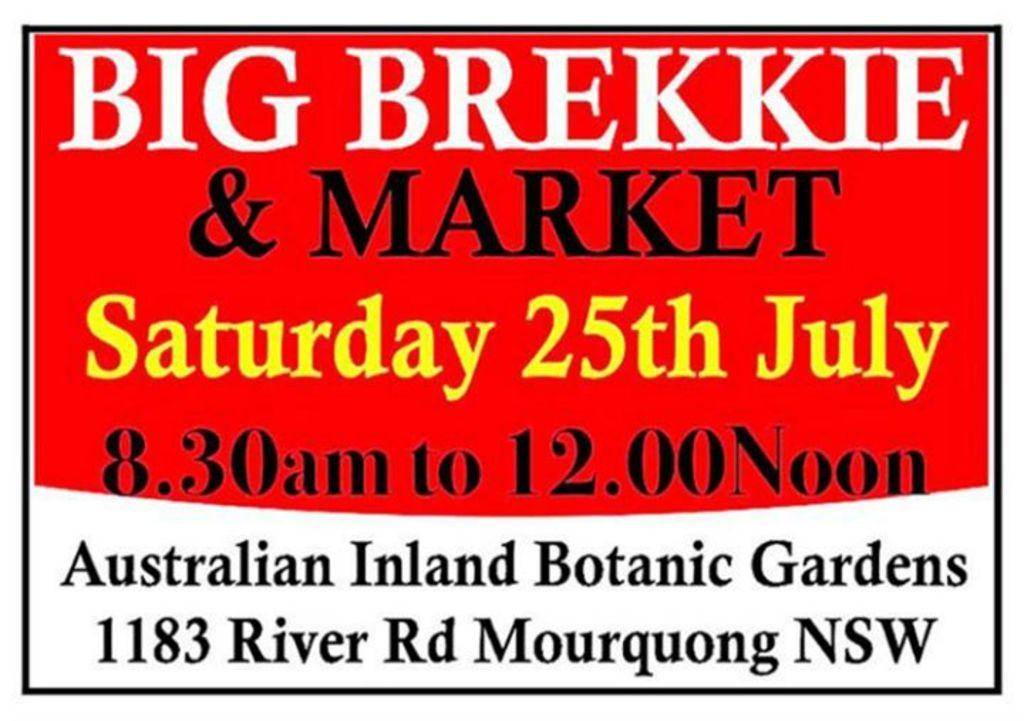<image>
Relay a brief, clear account of the picture shown. A breakfast and market will be on Saturday, July 25. 